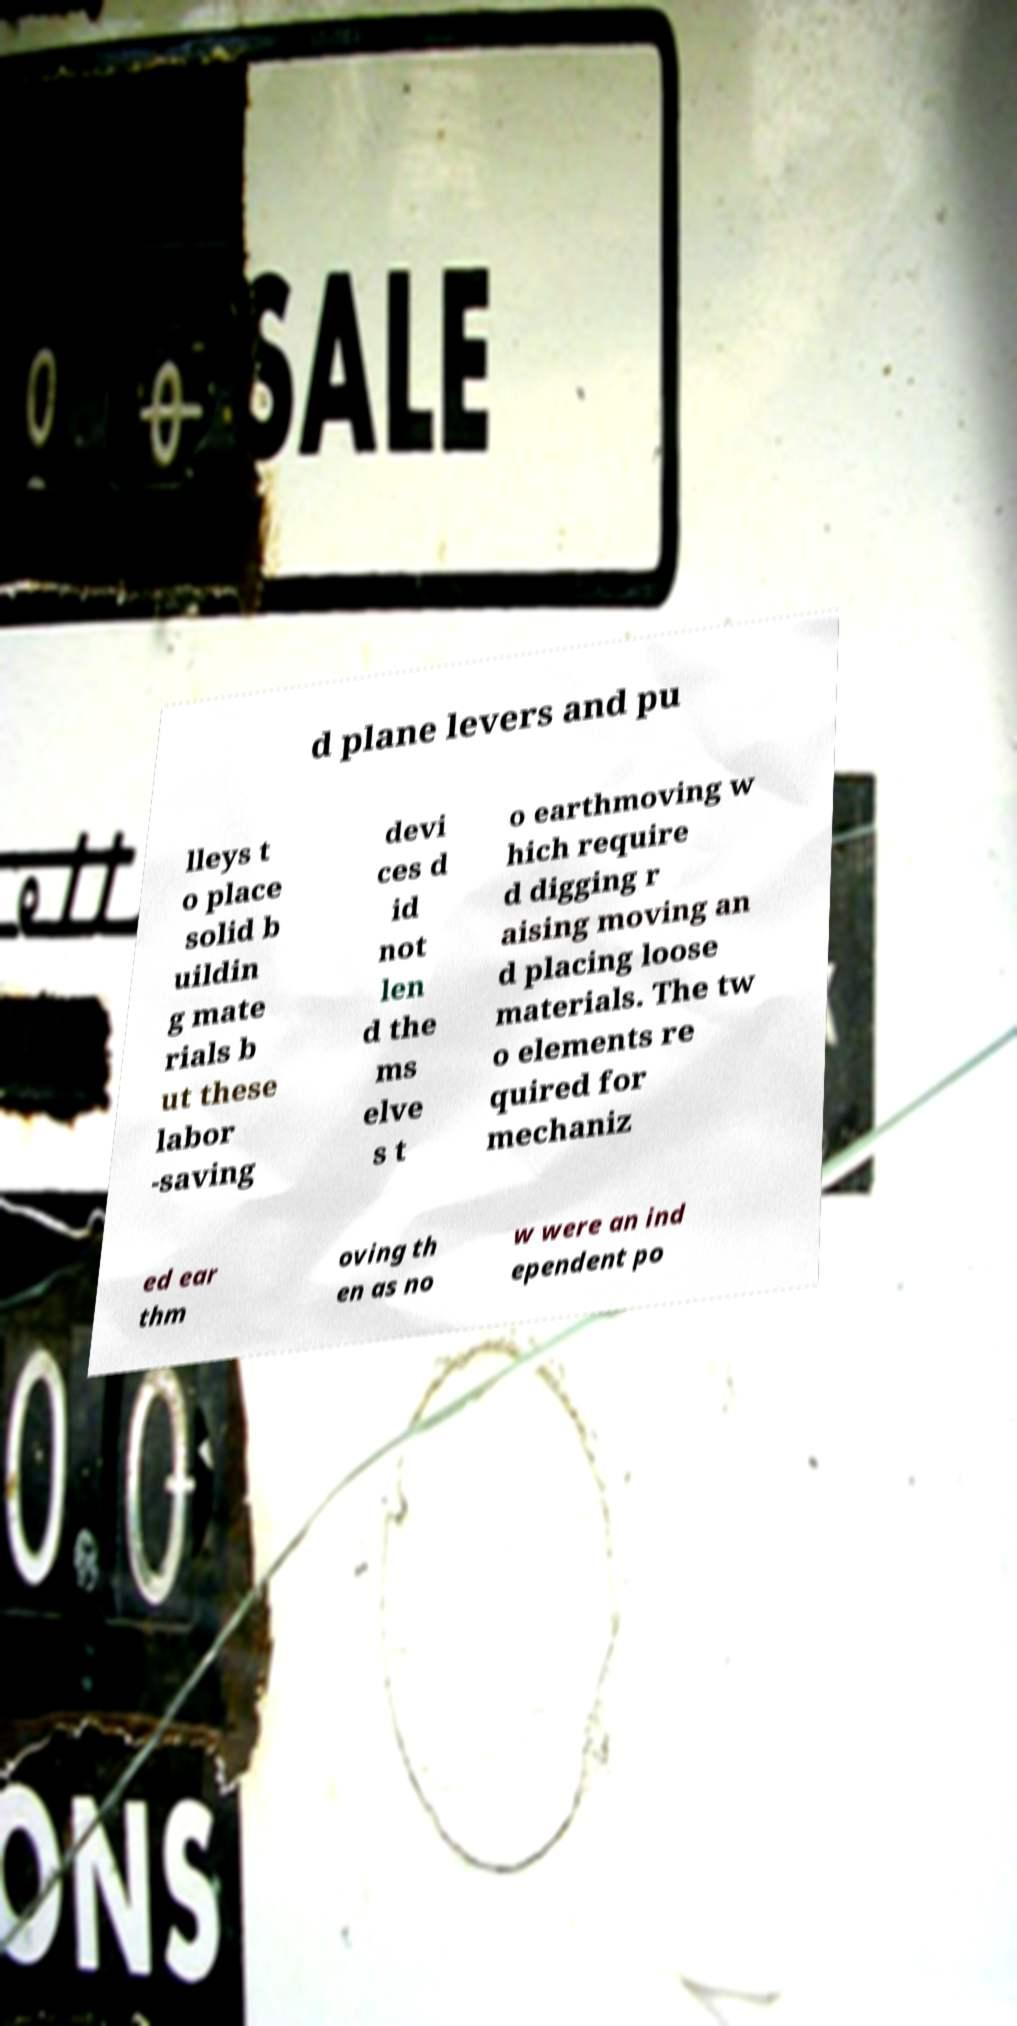What messages or text are displayed in this image? I need them in a readable, typed format. d plane levers and pu lleys t o place solid b uildin g mate rials b ut these labor -saving devi ces d id not len d the ms elve s t o earthmoving w hich require d digging r aising moving an d placing loose materials. The tw o elements re quired for mechaniz ed ear thm oving th en as no w were an ind ependent po 